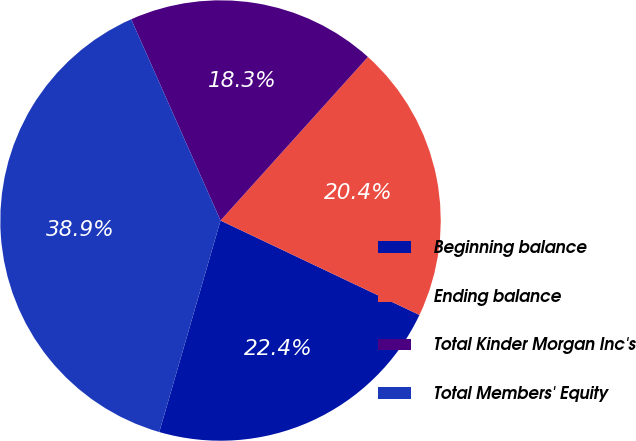Convert chart to OTSL. <chart><loc_0><loc_0><loc_500><loc_500><pie_chart><fcel>Beginning balance<fcel>Ending balance<fcel>Total Kinder Morgan Inc's<fcel>Total Members' Equity<nl><fcel>22.43%<fcel>20.38%<fcel>18.32%<fcel>38.86%<nl></chart> 